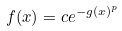<formula> <loc_0><loc_0><loc_500><loc_500>f ( x ) = c e ^ { - g ( x ) ^ { p } }</formula> 